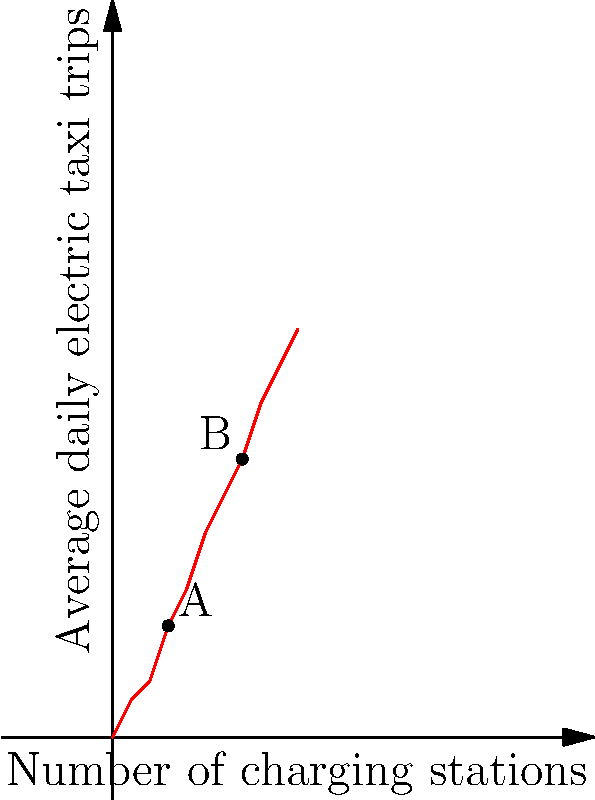The graph shows the relationship between the number of charging stations and the average daily electric taxi trips in a city. If the city currently has 3 charging stations (point A) and wants to increase to 7 stations (point B), by what percentage would the average daily electric taxi trips increase? To calculate the percentage increase in average daily electric taxi trips, we need to follow these steps:

1. Identify the number of average daily trips at point A (3 stations):
   $y_A = 6$ trips

2. Identify the number of average daily trips at point B (7 stations):
   $y_B = 15$ trips

3. Calculate the difference in trips:
   $\text{Difference} = y_B - y_A = 15 - 6 = 9$ trips

4. Calculate the percentage increase:
   $\text{Percentage increase} = \frac{\text{Difference}}{\text{Initial value}} \times 100\%$
   $= \frac{9}{6} \times 100\% = 1.5 \times 100\% = 150\%$

Therefore, increasing the number of charging stations from 3 to 7 would result in a 150% increase in average daily electric taxi trips.
Answer: 150% 